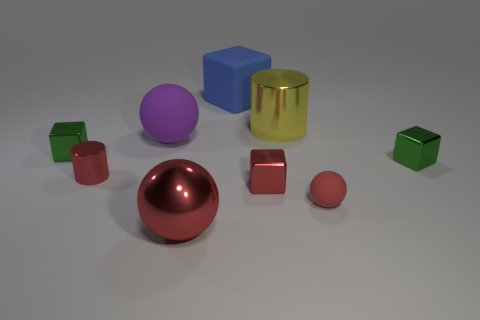Add 1 red metallic cylinders. How many objects exist? 10 Subtract all cylinders. How many objects are left? 7 Add 9 small matte objects. How many small matte objects exist? 10 Subtract 0 cyan blocks. How many objects are left? 9 Subtract all large matte cubes. Subtract all tiny cylinders. How many objects are left? 7 Add 1 big red metallic objects. How many big red metallic objects are left? 2 